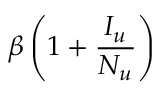Convert formula to latex. <formula><loc_0><loc_0><loc_500><loc_500>\beta \left ( 1 + \frac { I _ { u } } { N _ { u } } \right )</formula> 